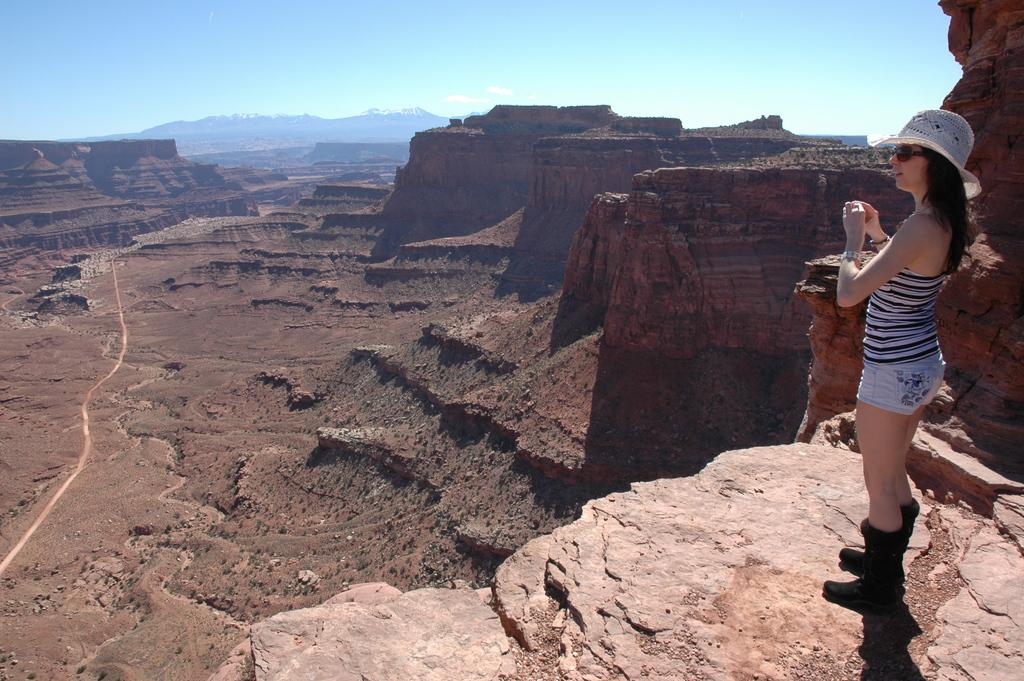What is the main subject of the image? There is a girl standing in the image. What can be seen in the background of the image? There are mountains and the sky visible in the background of the image. Where is the crib located in the image? There is no crib present in the image. What type of donkey can be seen interacting with the girl in the image? There is no donkey present in the image. 